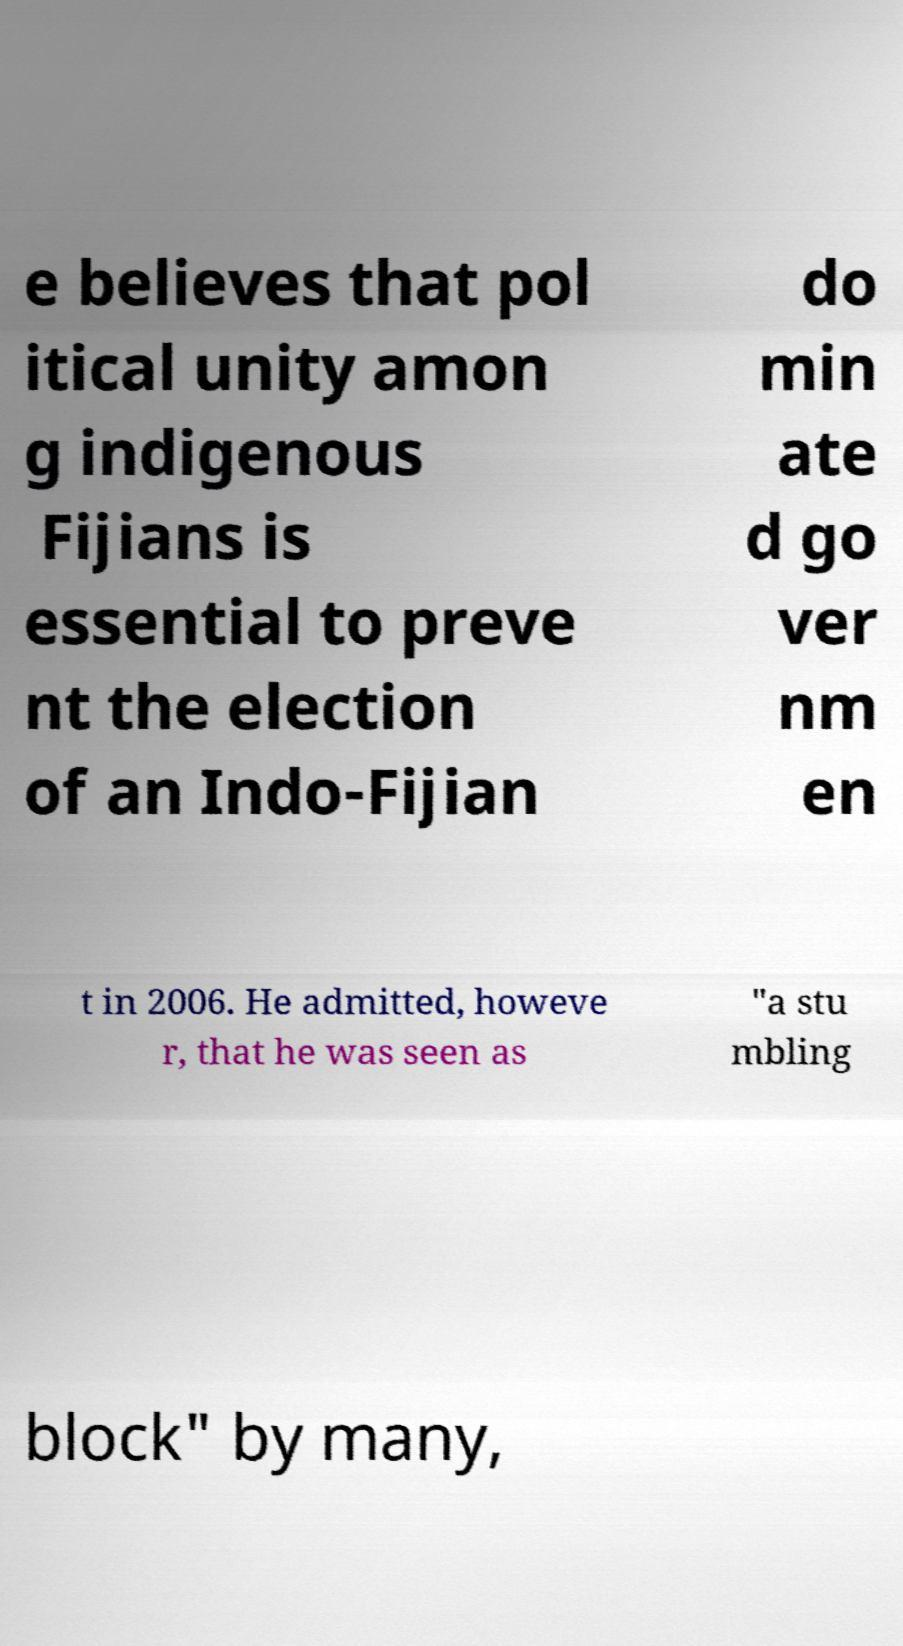Could you assist in decoding the text presented in this image and type it out clearly? e believes that pol itical unity amon g indigenous Fijians is essential to preve nt the election of an Indo-Fijian do min ate d go ver nm en t in 2006. He admitted, howeve r, that he was seen as "a stu mbling block" by many, 